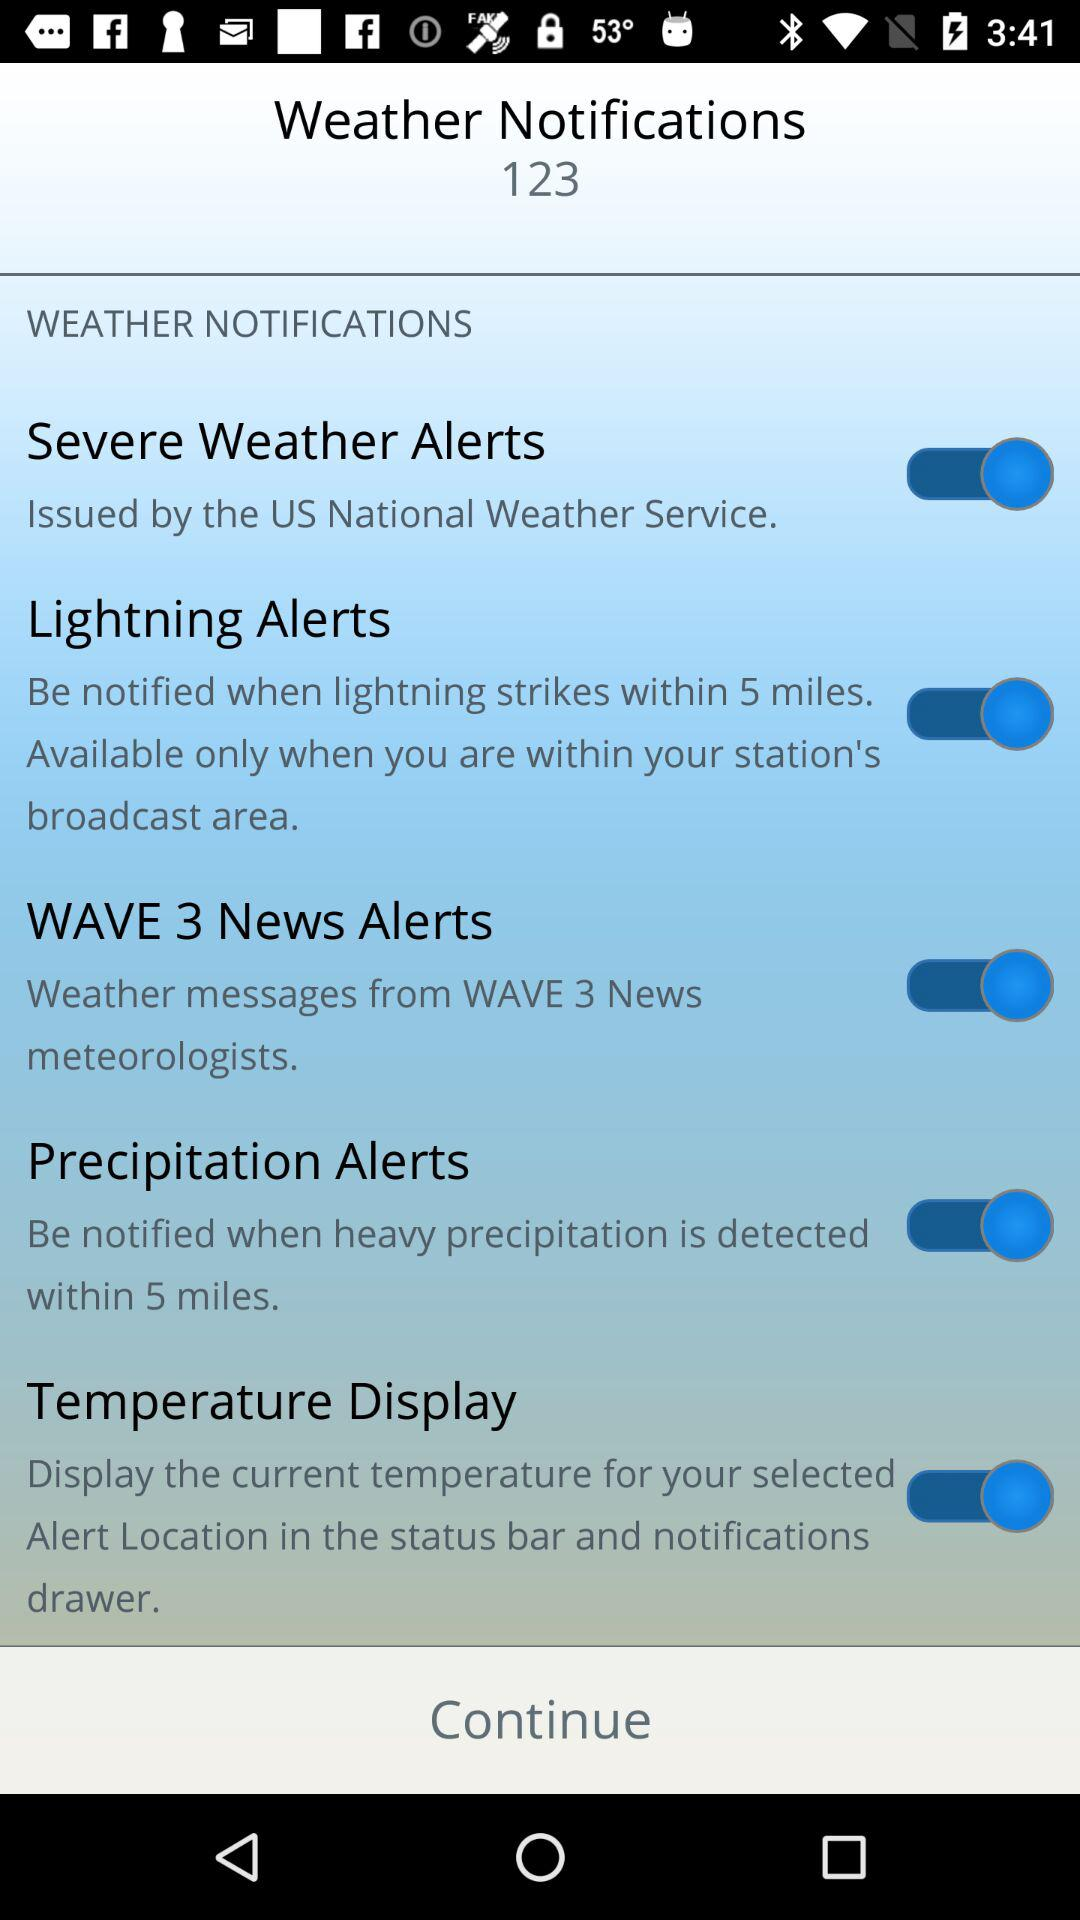Who issues "Severe Weather Alerts"? The "Severe Weather Alert" is issued by the "US National Weather Service". 